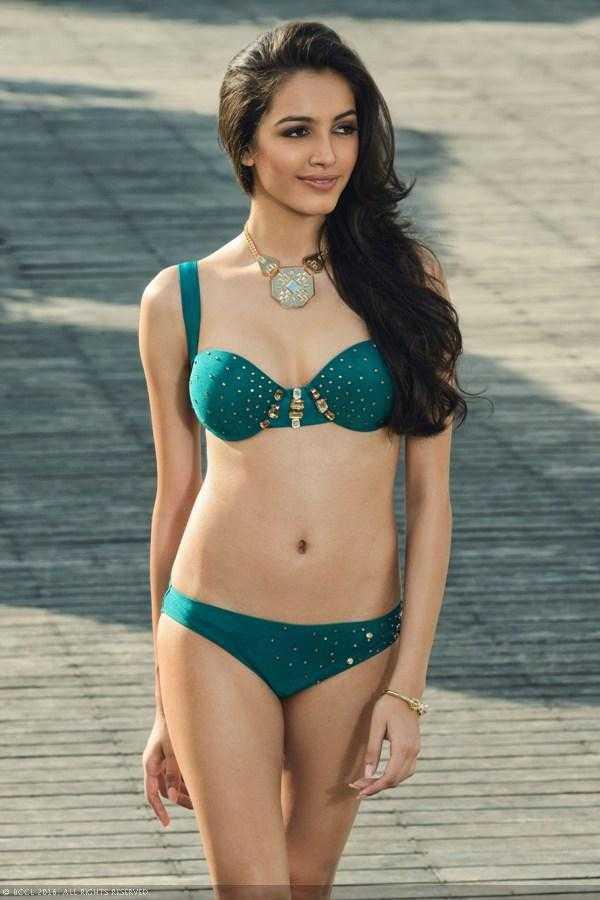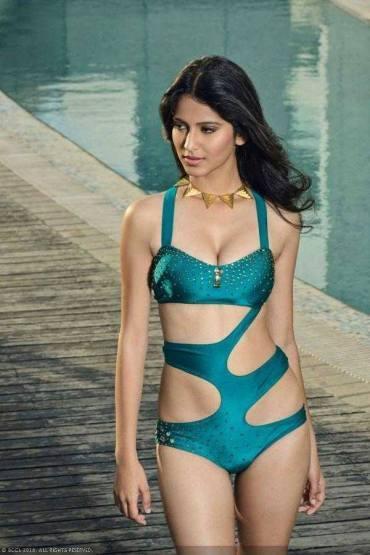The first image is the image on the left, the second image is the image on the right. Assess this claim about the two images: "An image shows a standing model in a teal bikini with her long black hair swept to the right side and her gaze aimed rightward.". Correct or not? Answer yes or no. Yes. The first image is the image on the left, the second image is the image on the right. For the images displayed, is the sentence "A woman is touching her hair." factually correct? Answer yes or no. No. 